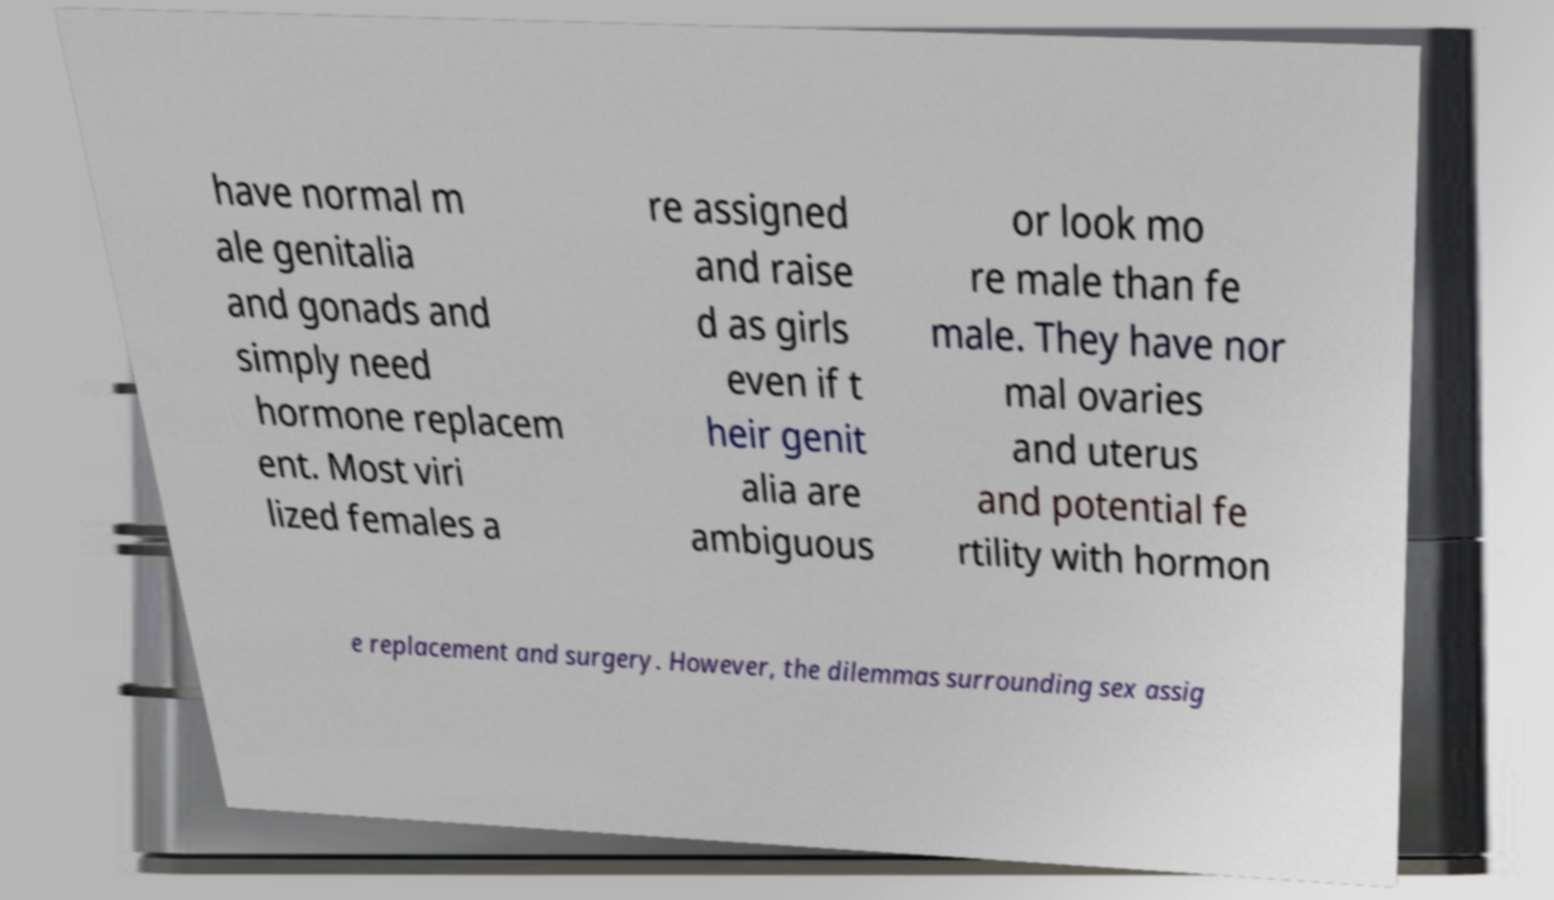Could you extract and type out the text from this image? have normal m ale genitalia and gonads and simply need hormone replacem ent. Most viri lized females a re assigned and raise d as girls even if t heir genit alia are ambiguous or look mo re male than fe male. They have nor mal ovaries and uterus and potential fe rtility with hormon e replacement and surgery. However, the dilemmas surrounding sex assig 